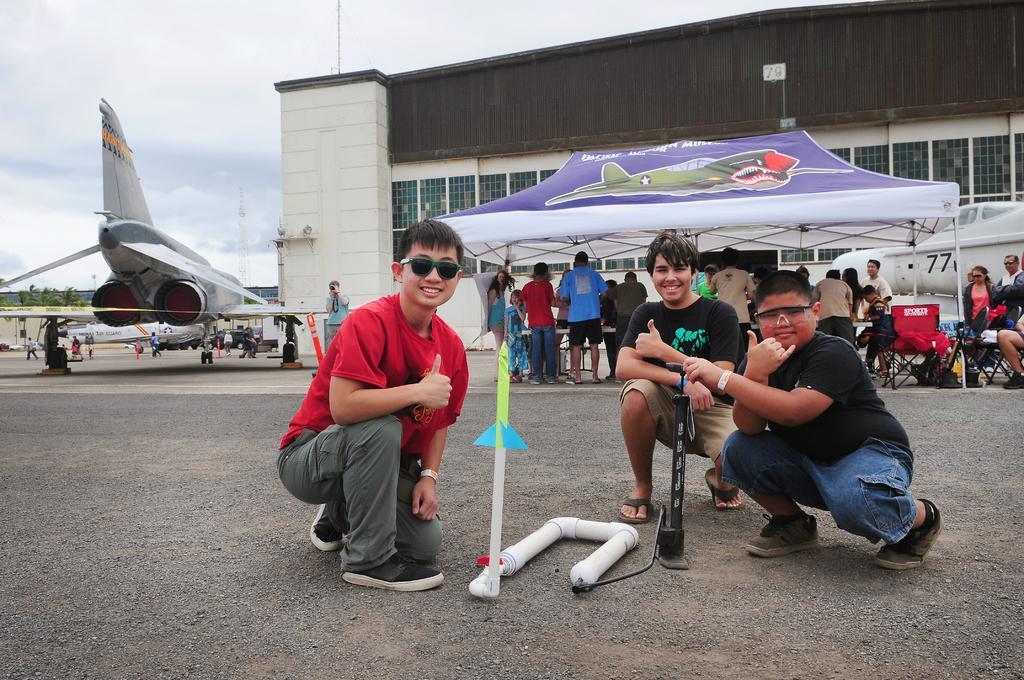Can you describe this image briefly? In this image I can see three people. In-front of these people I can see the air-pump and the tube. In the background I can see the tent, many aircraft, the group of people with different color dress and the vehicles. I can also see the building, clouds and the sky. 